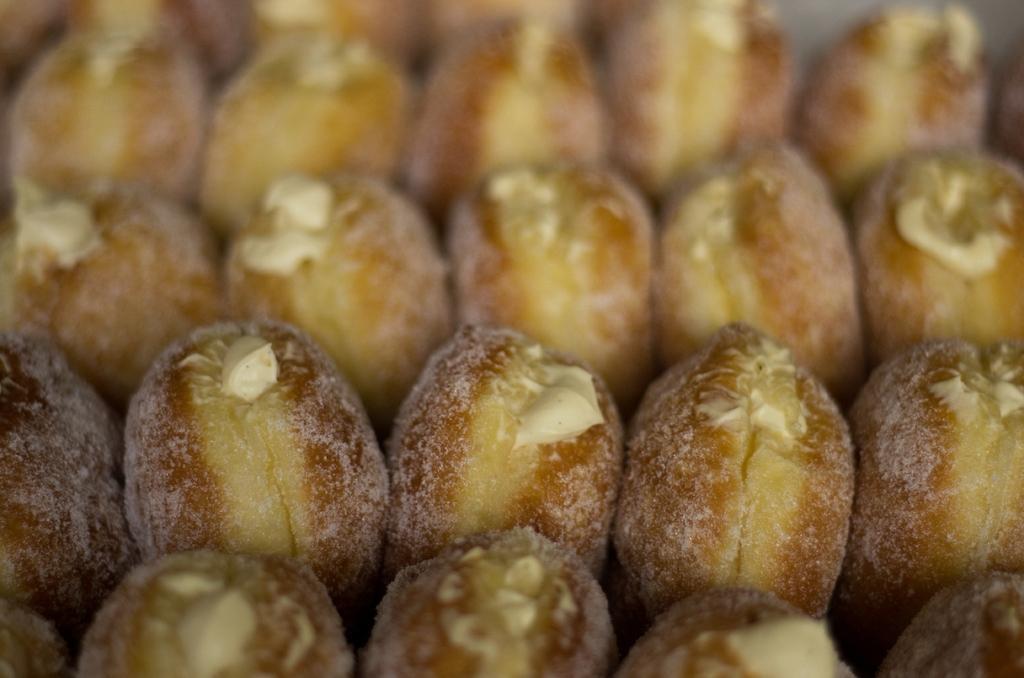Please provide a concise description of this image. This image consist of food. 